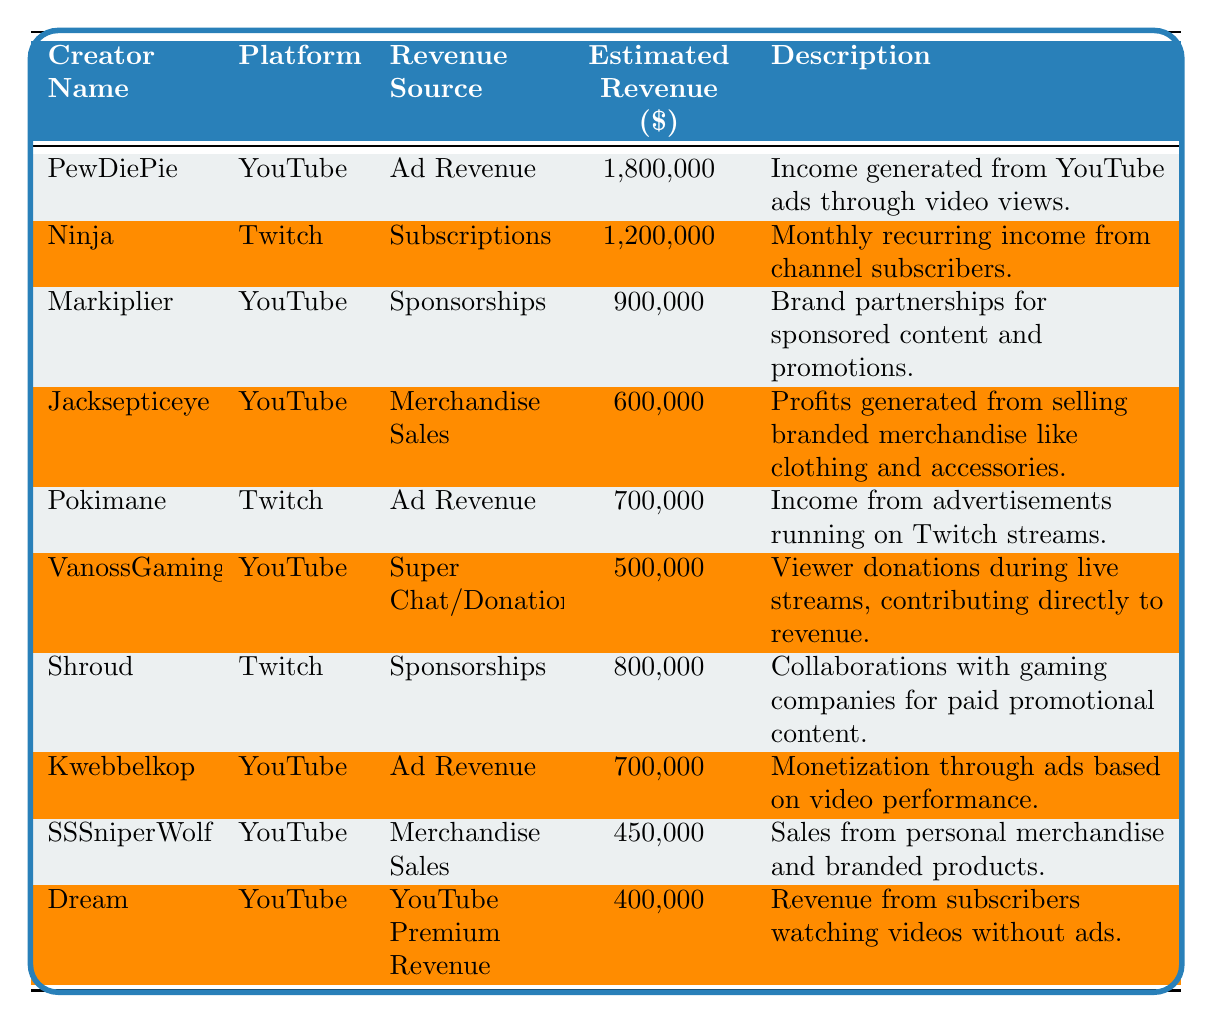What is the highest estimated revenue among all creators? The table shows estimated revenues for different creators, with PewDiePie having the highest revenue at $1,800,000.
Answer: $1,800,000 How much revenue does Ninja generate from subscriptions? The table states that Ninja, on Twitch, generates an estimated revenue of $1,200,000 from subscriptions.
Answer: $1,200,000 Is Shroud's revenue from sponsorships greater than $700,000? Shroud's revenue from sponsorships is $800,000, which is indeed greater than $700,000.
Answer: Yes What is the total revenue generated from merchandise sales by Jacksepticeye and SSSniperWolf? Jacksepticeye has $600,000 from merchandise sales and SSSniperWolf has $450,000. Therefore, the total revenue is $600,000 + $450,000 = $1,050,000.
Answer: $1,050,000 Which platforms do creators mainly generate ad revenue from? The table indicates that both PewDiePie and Pokimane generate revenue from ads on YouTube and Twitch, respectively.
Answer: YouTube and Twitch What is the average estimated revenue of the creators listed? The total estimated revenue for all creators adds up to $5,650,000, and with 10 creators, the average is $5,650,000 / 10 = $565,000.
Answer: $565,000 Are there more creators on YouTube than on Twitch? The table lists 6 creators from YouTube and 4 from Twitch, confirming that there are more on YouTube.
Answer: Yes How much more revenue does PewDiePie make compared to Dream? PewDiePie makes $1,800,000 while Dream makes $400,000. The difference is $1,800,000 - $400,000 = $1,400,000.
Answer: $1,400,000 Is the sum of Ad Revenue from YouTube creators more than from Twitch creators? PewDiePie and Kwebbelkop together generate $2,500,000, while Pokimane generates $700,000. $2,500,000 > $700,000 indicates that YouTube creators generate more.
Answer: Yes What percentage of the total estimated revenue does Shroud's sponsorship revenue represent? Shroud's sponsorship revenue is $800,000. The total revenue is $5,650,000, and the percentage is ($800,000 / $5,650,000) * 100 ≈ 14.1%.
Answer: 14.1% 